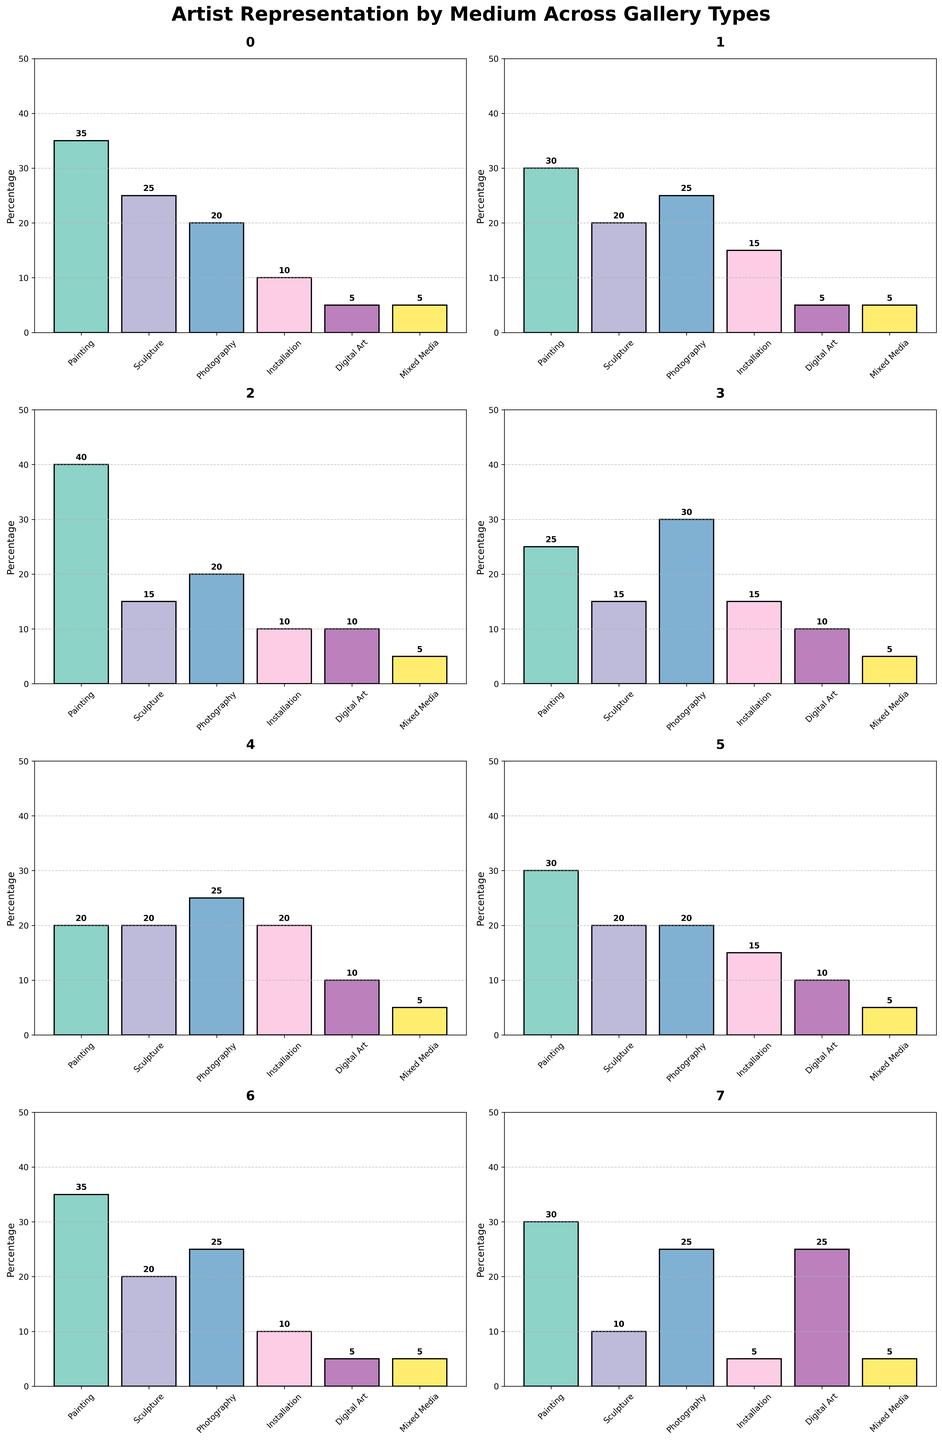What artistic medium is most represented in Large Galleries? In the bar chart for Large Galleries, the tallest bar represents Painting with a value of 35. Thus, Painting is the most represented medium.
Answer: Painting Which type of gallery has the highest representation of Digital Art? In the subplots, Online Platforms have the highest bar for Digital Art with a value of 25. Thus, Online Platforms have the highest representation.
Answer: Online Platforms How does the percentage of Painting representation compare between Large Galleries and Small Galleries? In the subplots, Large Galleries have a 35% representation for Painting, whereas Small Galleries have a 40% representation for Painting. Comparing these, Small Galleries have a higher percentage.
Answer: Small Galleries Among the gallery types, which one has the least representation of Installation art? For all gallery types in the subplots, Online Platforms have the lowest Installation art percentage with a value of 5.
Answer: Online Platforms What is the combined percentage of Sculpture and Photography representation in Mid-Size Galleries? For Mid-Size Galleries, the percentage of Sculpture is 20 and Photography is 25. Adding these together gives 20 + 25 = 45.
Answer: 45 Which gallery type has an equal percentage representation of Painting and Photography? In the subplots, University Galleries have an equal percentage representation of Painting and Photography at 20% each.
Answer: University Galleries In Contemporary Art Centers, by how much does the Digital Art representation exceed that of Large Galleries? The Digital Art representation in Contemporary Art Centers is 10%, and in Large Galleries, it is 5%. The difference is 10 - 5 = 5.
Answer: 5 For Emerging Artist Spaces, which artistic medium has the second highest representation? For Emerging Artist Spaces, the bar for Photography is at 30%, which is the highest. The second highest is tied between Sculpture and Installation at 15% each.
Answer: Sculpture and Installation Across all gallery types, which artistic medium has the highest average representation? Summing the representation percentages for each medium across all gallery types and then dividing by the number of types (8) gives the following: Painting: (35+30+40+25+20+30+35+30)/8 = 30.625; Sculpture: (25+20+15+15+20+20+20+10)/8 = 18.125; Photography: (20+25+20+30+25+20+25+25)/8 = 23.75; Installation: (10+15+10+15+20+15+10+5)/8 = 12.5; Digital Art: (5+5+10+10+10+10+5+25)/8 = 10. Music Media: (5+5+5+5+5+5+5+5)/8 = 5. Hence, Painting has the highest average representation.
Answer: Painting What is the difference between the highest percentage of Mixed Media representation and the lowest among all gallery types? All gallery types show Mixed Media representation at 5%. Therefore, the difference is 5 - 5 = 0.
Answer: 0 